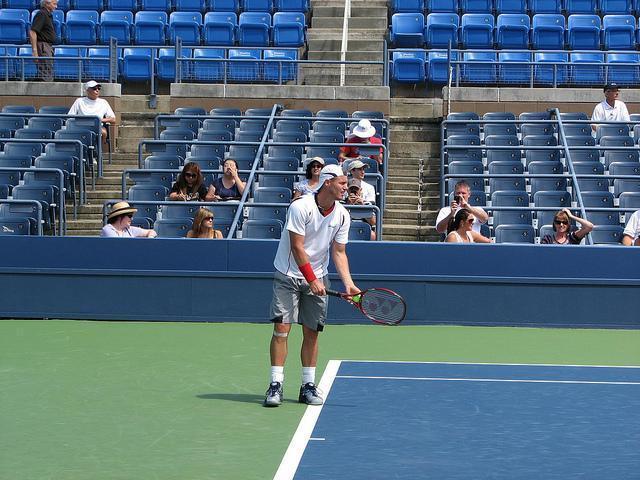How many chairs are in the photo?
Give a very brief answer. 2. How many people are in the photo?
Give a very brief answer. 2. 